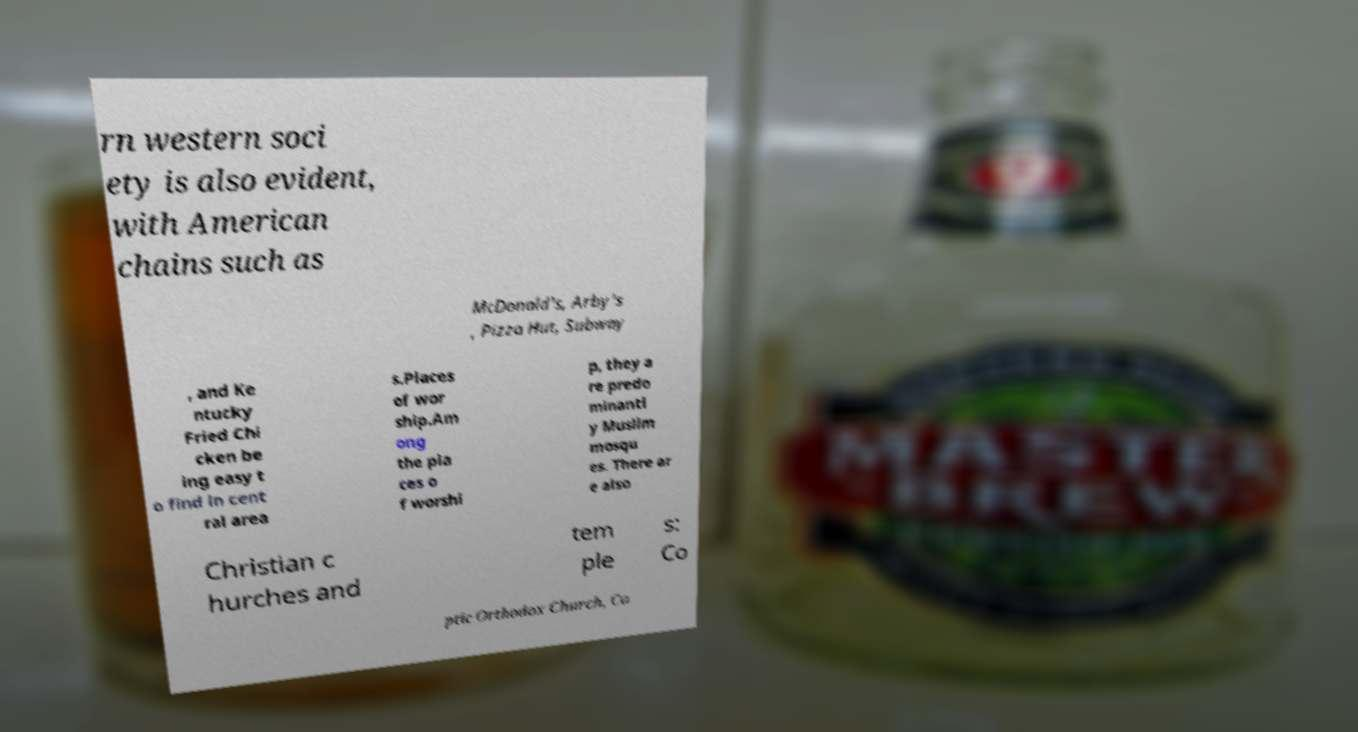Can you accurately transcribe the text from the provided image for me? rn western soci ety is also evident, with American chains such as McDonald's, Arby's , Pizza Hut, Subway , and Ke ntucky Fried Chi cken be ing easy t o find in cent ral area s.Places of wor ship.Am ong the pla ces o f worshi p, they a re predo minantl y Muslim mosqu es. There ar e also Christian c hurches and tem ple s: Co ptic Orthodox Church, Co 